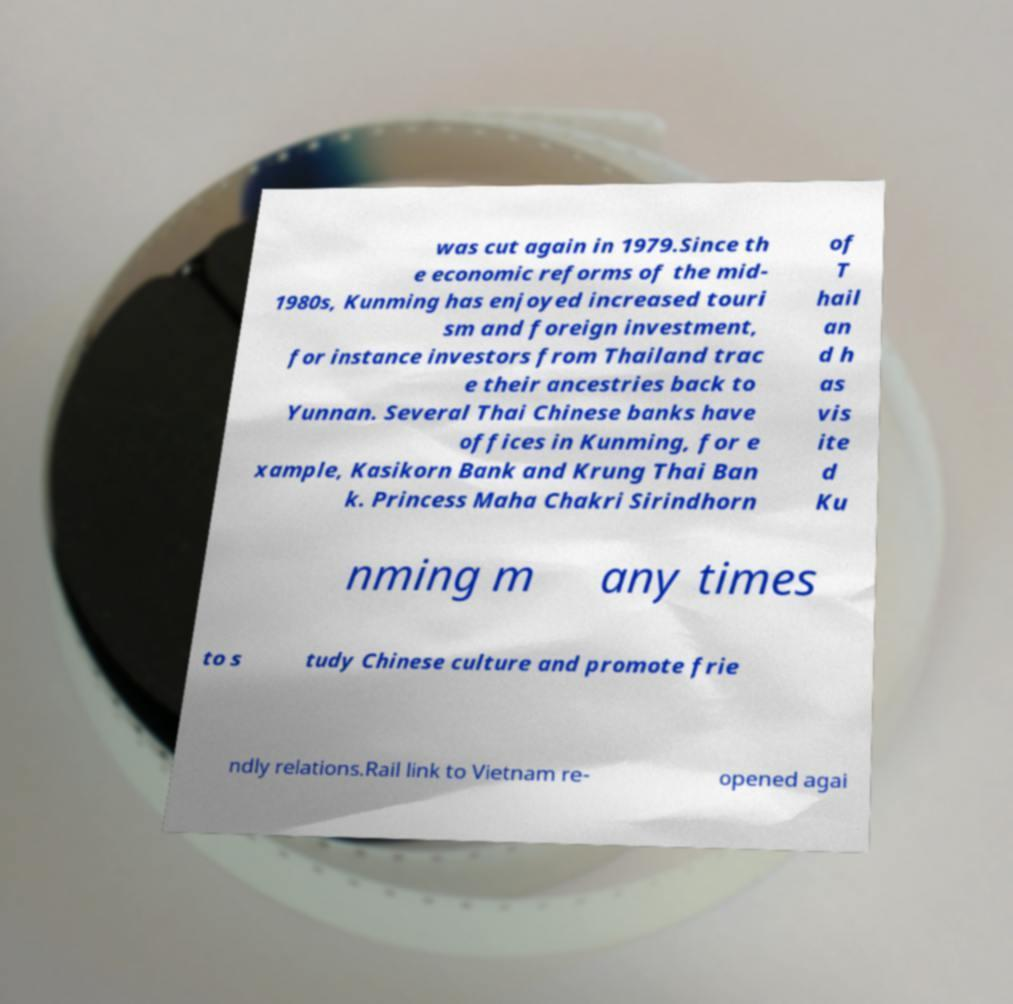Please read and relay the text visible in this image. What does it say? was cut again in 1979.Since th e economic reforms of the mid- 1980s, Kunming has enjoyed increased touri sm and foreign investment, for instance investors from Thailand trac e their ancestries back to Yunnan. Several Thai Chinese banks have offices in Kunming, for e xample, Kasikorn Bank and Krung Thai Ban k. Princess Maha Chakri Sirindhorn of T hail an d h as vis ite d Ku nming m any times to s tudy Chinese culture and promote frie ndly relations.Rail link to Vietnam re- opened agai 